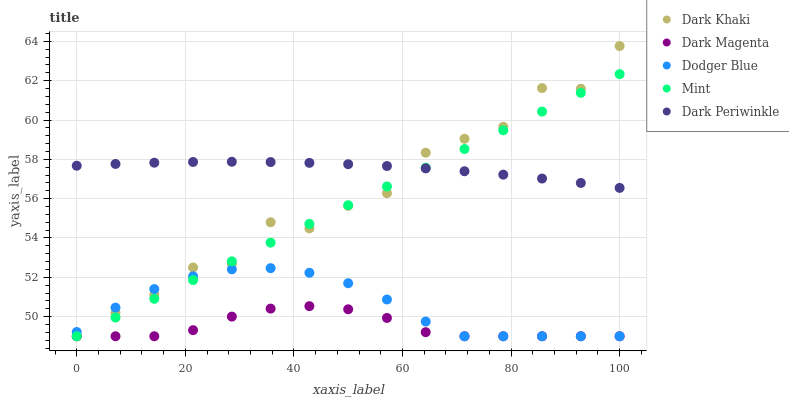Does Dark Magenta have the minimum area under the curve?
Answer yes or no. Yes. Does Dark Periwinkle have the maximum area under the curve?
Answer yes or no. Yes. Does Mint have the minimum area under the curve?
Answer yes or no. No. Does Mint have the maximum area under the curve?
Answer yes or no. No. Is Mint the smoothest?
Answer yes or no. Yes. Is Dark Khaki the roughest?
Answer yes or no. Yes. Is Dodger Blue the smoothest?
Answer yes or no. No. Is Dodger Blue the roughest?
Answer yes or no. No. Does Dark Khaki have the lowest value?
Answer yes or no. Yes. Does Dark Periwinkle have the lowest value?
Answer yes or no. No. Does Dark Khaki have the highest value?
Answer yes or no. Yes. Does Mint have the highest value?
Answer yes or no. No. Is Dodger Blue less than Dark Periwinkle?
Answer yes or no. Yes. Is Dark Periwinkle greater than Dodger Blue?
Answer yes or no. Yes. Does Dark Magenta intersect Dark Khaki?
Answer yes or no. Yes. Is Dark Magenta less than Dark Khaki?
Answer yes or no. No. Is Dark Magenta greater than Dark Khaki?
Answer yes or no. No. Does Dodger Blue intersect Dark Periwinkle?
Answer yes or no. No. 